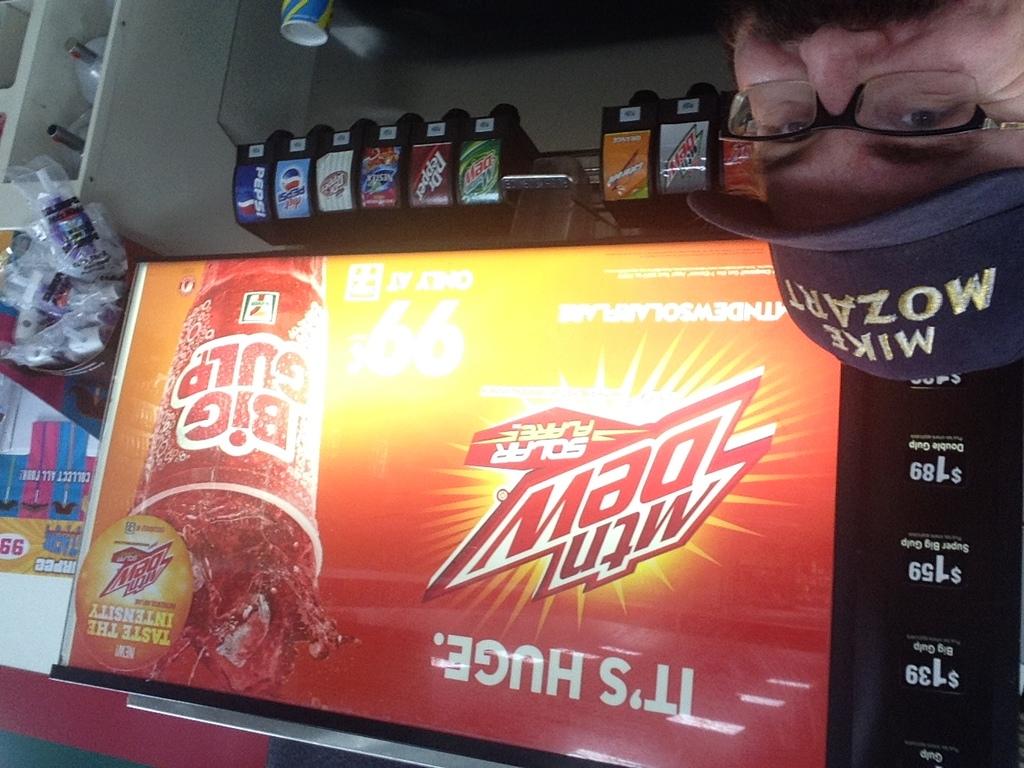What drink is advertised?
Your answer should be very brief. Mtn dew. 